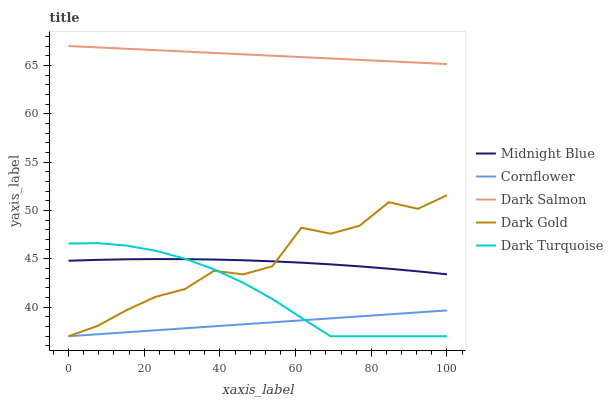Does Cornflower have the minimum area under the curve?
Answer yes or no. Yes. Does Dark Salmon have the maximum area under the curve?
Answer yes or no. Yes. Does Dark Gold have the minimum area under the curve?
Answer yes or no. No. Does Dark Gold have the maximum area under the curve?
Answer yes or no. No. Is Cornflower the smoothest?
Answer yes or no. Yes. Is Dark Gold the roughest?
Answer yes or no. Yes. Is Midnight Blue the smoothest?
Answer yes or no. No. Is Midnight Blue the roughest?
Answer yes or no. No. Does Cornflower have the lowest value?
Answer yes or no. Yes. Does Midnight Blue have the lowest value?
Answer yes or no. No. Does Dark Salmon have the highest value?
Answer yes or no. Yes. Does Dark Gold have the highest value?
Answer yes or no. No. Is Midnight Blue less than Dark Salmon?
Answer yes or no. Yes. Is Dark Salmon greater than Dark Gold?
Answer yes or no. Yes. Does Cornflower intersect Dark Gold?
Answer yes or no. Yes. Is Cornflower less than Dark Gold?
Answer yes or no. No. Is Cornflower greater than Dark Gold?
Answer yes or no. No. Does Midnight Blue intersect Dark Salmon?
Answer yes or no. No. 